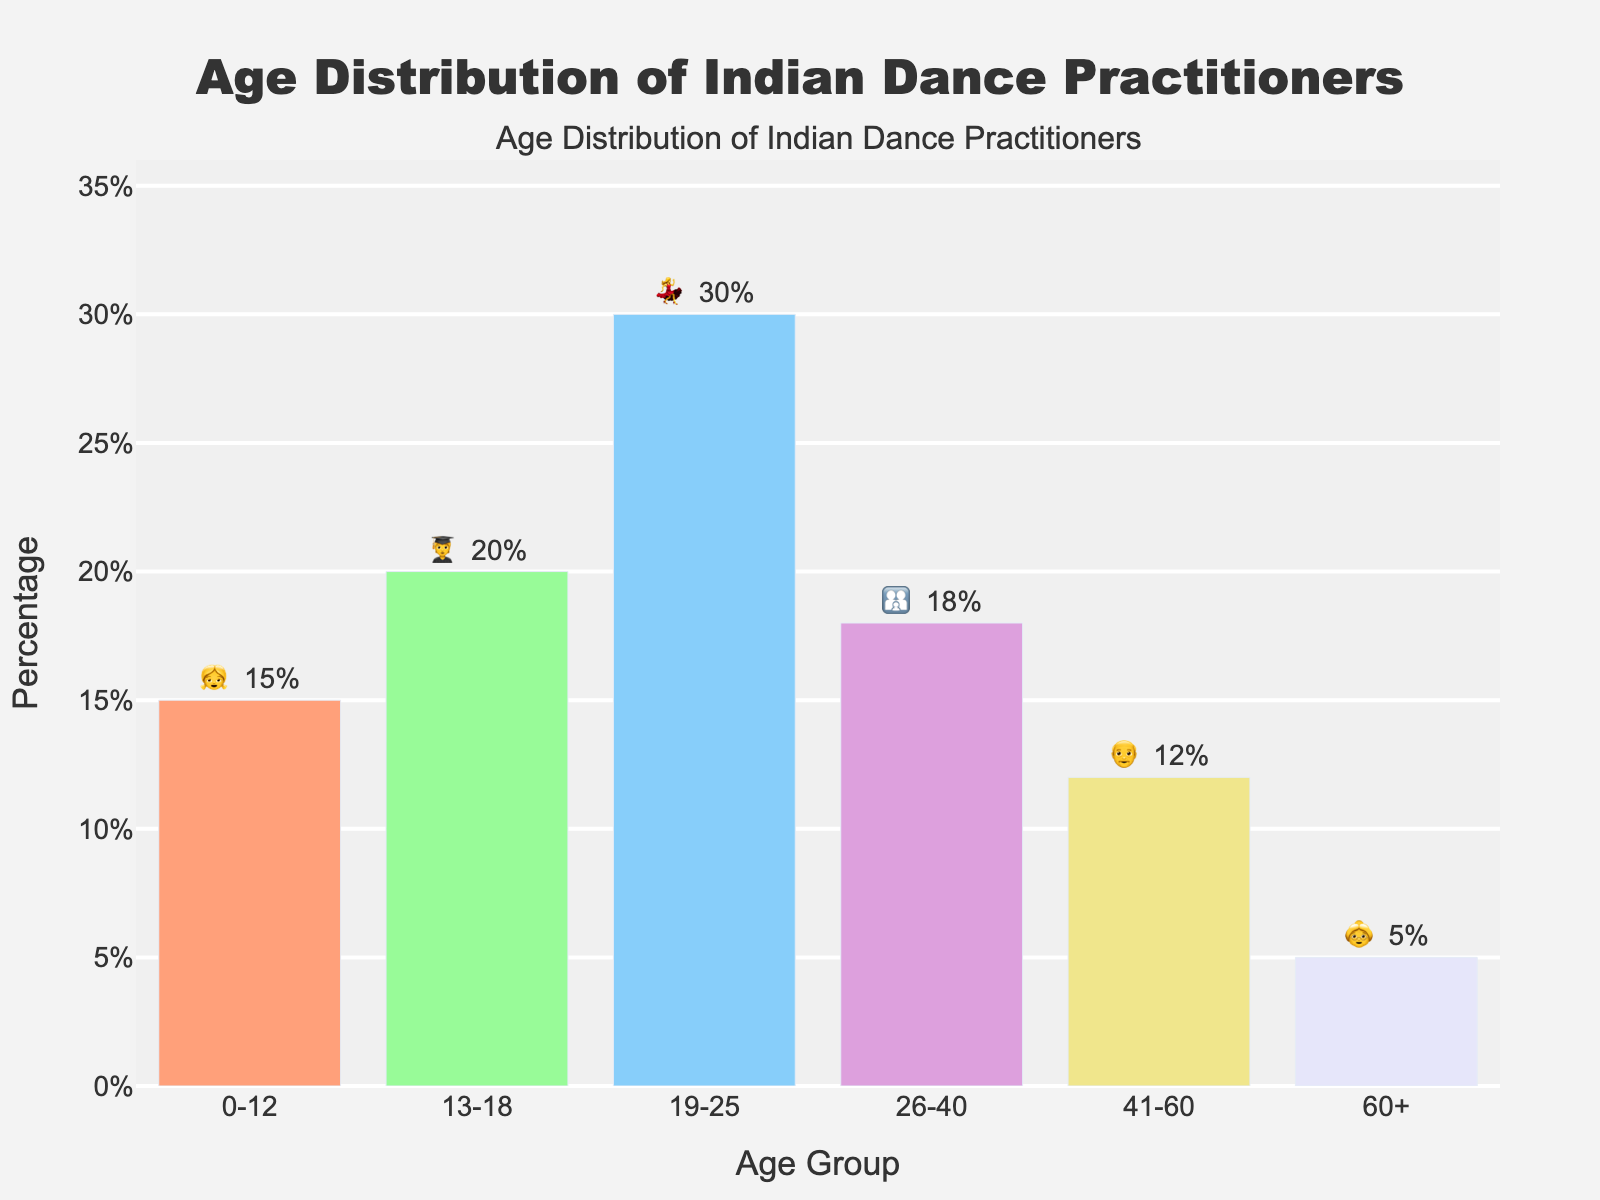What's the title of the figure? The title of the figure is located at the top and reads "Age Distribution of Indian Dance Practitioners".
Answer: Age Distribution of Indian Dance Practitioners Which age group has the highest percentage of Indian dance practitioners? The age group with the highest percentage is represented by a bar that reaches the highest point on the y-axis. The 19-25 age group shows the highest percentage at 30%.
Answer: 19-25 What's the combined percentage of practitioners aged 0-12 and 60+? Add the percentages of the 0-12 group (15%) and the 60+ group (5%). 15% + 5% = 20%.
Answer: 20% How does the percentage of the 41-60 age group compare to that of the 13-18 age group? Compare the height of the bars for the 41-60 age group (12%) and the 13-18 age group (20%). The bar for the 13-18 group is taller, indicating a higher percentage.
Answer: 13-18 age group has a higher percentage What is the emoji used to represent the 26-40 age group and what percentage does it represent? Look at the bar corresponding to the 26-40 age group and note the emoji and percentage. The emoji is 👨‍👩‍👧, and the percentage is 18%.
Answer: 👨‍👩‍👧, 18% Is there a significant drop in the percentage of dance practitioners as the age group increases from 41-60 to 60+? Compare the percentages for the 41-60 age group (12%) and the 60+ age group (5%). The difference is 12% - 5% = 7%, indicating a significant drop.
Answer: Yes, significant drop Which age group has a close percentage to 20% and what emoji represents it? Identify the age groups and percentages, then locate the group closest to 20%. The 13-18 age group is exactly 20%, represented by emoji 🧑‍🎓.
Answer: 13-18, 🧑‍🎓 What's the average percentage of practitioners in the age groups 19-25 and 26-40? Calculate the average by adding the percentages of the 19-25 (30%) and 26-40 (18%) age groups, then divide by 2. (30% + 18%) / 2 = 24%.
Answer: 24% How many age groups have a percentage below 15%? Count the number of bars with percentages below 15%. The age groups 41-60 (12%) and 60+ (5%) are below 15%, so there are 2 groups.
Answer: 2 groups What is the total percentage represented by the age groups 0-12, 13-18, and 19-25? Add the percentages of the 0-12 (15%), 13-18 (20%), and 19-25 (30%) age groups. 15% + 20% + 30% = 65%.
Answer: 65% 